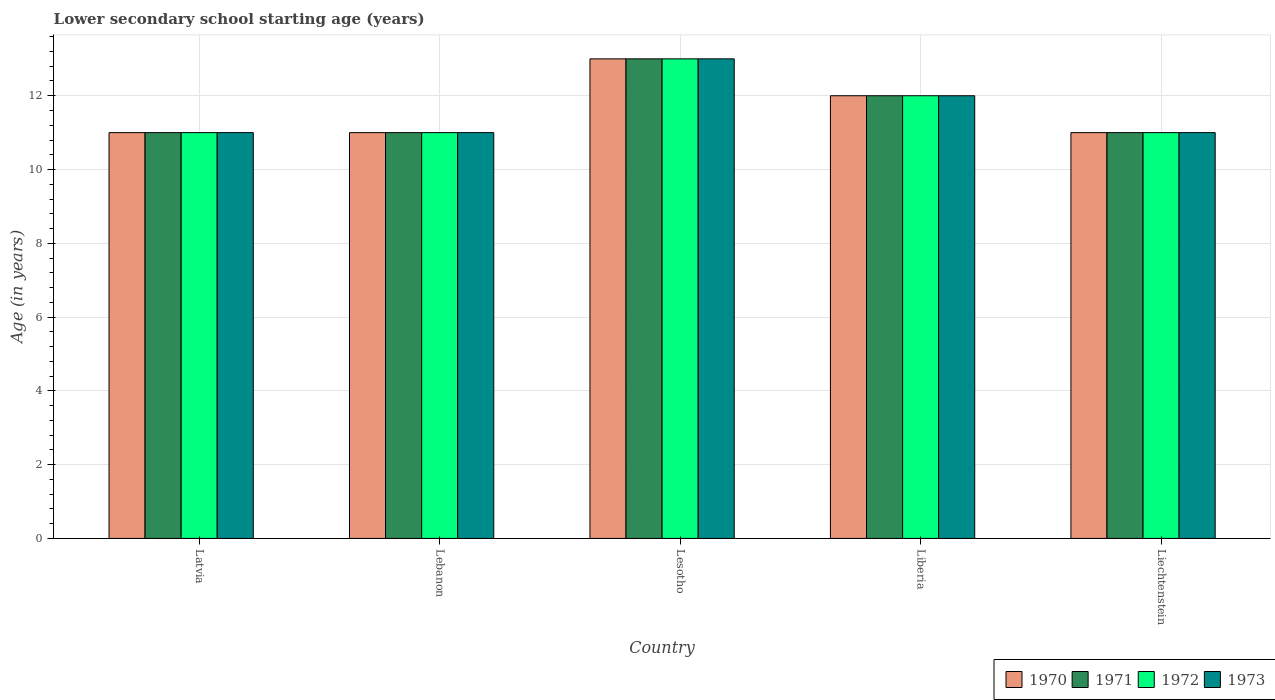How many different coloured bars are there?
Offer a terse response. 4. How many groups of bars are there?
Your answer should be compact. 5. Are the number of bars per tick equal to the number of legend labels?
Provide a succinct answer. Yes. Are the number of bars on each tick of the X-axis equal?
Give a very brief answer. Yes. What is the label of the 5th group of bars from the left?
Your response must be concise. Liechtenstein. In how many cases, is the number of bars for a given country not equal to the number of legend labels?
Your answer should be very brief. 0. Across all countries, what is the maximum lower secondary school starting age of children in 1972?
Give a very brief answer. 13. Across all countries, what is the minimum lower secondary school starting age of children in 1973?
Your response must be concise. 11. In which country was the lower secondary school starting age of children in 1973 maximum?
Ensure brevity in your answer.  Lesotho. In which country was the lower secondary school starting age of children in 1971 minimum?
Keep it short and to the point. Latvia. What is the difference between the lower secondary school starting age of children in 1973 in Lesotho and that in Liberia?
Your answer should be very brief. 1. What is the difference between the lower secondary school starting age of children of/in 1973 and lower secondary school starting age of children of/in 1972 in Latvia?
Ensure brevity in your answer.  0. What is the ratio of the lower secondary school starting age of children in 1970 in Lebanon to that in Lesotho?
Ensure brevity in your answer.  0.85. Is the lower secondary school starting age of children in 1972 in Lebanon less than that in Lesotho?
Provide a succinct answer. Yes. What is the difference between the highest and the second highest lower secondary school starting age of children in 1972?
Your answer should be compact. -1. In how many countries, is the lower secondary school starting age of children in 1973 greater than the average lower secondary school starting age of children in 1973 taken over all countries?
Your answer should be compact. 2. Is the sum of the lower secondary school starting age of children in 1972 in Liberia and Liechtenstein greater than the maximum lower secondary school starting age of children in 1971 across all countries?
Provide a succinct answer. Yes. Is it the case that in every country, the sum of the lower secondary school starting age of children in 1972 and lower secondary school starting age of children in 1971 is greater than the lower secondary school starting age of children in 1970?
Your answer should be compact. Yes. How many bars are there?
Provide a succinct answer. 20. Are all the bars in the graph horizontal?
Your answer should be compact. No. What is the difference between two consecutive major ticks on the Y-axis?
Provide a succinct answer. 2. Are the values on the major ticks of Y-axis written in scientific E-notation?
Give a very brief answer. No. Does the graph contain any zero values?
Provide a succinct answer. No. Does the graph contain grids?
Make the answer very short. Yes. Where does the legend appear in the graph?
Your answer should be very brief. Bottom right. How many legend labels are there?
Your answer should be compact. 4. What is the title of the graph?
Your answer should be compact. Lower secondary school starting age (years). Does "1994" appear as one of the legend labels in the graph?
Offer a very short reply. No. What is the label or title of the Y-axis?
Offer a very short reply. Age (in years). What is the Age (in years) in 1970 in Lebanon?
Your response must be concise. 11. What is the Age (in years) of 1973 in Lebanon?
Ensure brevity in your answer.  11. What is the Age (in years) in 1971 in Lesotho?
Your answer should be very brief. 13. What is the Age (in years) of 1972 in Lesotho?
Give a very brief answer. 13. What is the Age (in years) in 1971 in Liechtenstein?
Provide a short and direct response. 11. Across all countries, what is the maximum Age (in years) in 1970?
Provide a short and direct response. 13. Across all countries, what is the maximum Age (in years) of 1972?
Offer a terse response. 13. Across all countries, what is the maximum Age (in years) of 1973?
Give a very brief answer. 13. Across all countries, what is the minimum Age (in years) in 1971?
Offer a terse response. 11. Across all countries, what is the minimum Age (in years) in 1972?
Make the answer very short. 11. Across all countries, what is the minimum Age (in years) of 1973?
Give a very brief answer. 11. What is the total Age (in years) in 1970 in the graph?
Make the answer very short. 58. What is the total Age (in years) of 1972 in the graph?
Make the answer very short. 58. What is the difference between the Age (in years) of 1972 in Latvia and that in Lebanon?
Your answer should be very brief. 0. What is the difference between the Age (in years) of 1971 in Latvia and that in Liberia?
Make the answer very short. -1. What is the difference between the Age (in years) of 1973 in Latvia and that in Liberia?
Offer a very short reply. -1. What is the difference between the Age (in years) in 1970 in Latvia and that in Liechtenstein?
Offer a very short reply. 0. What is the difference between the Age (in years) in 1971 in Latvia and that in Liechtenstein?
Ensure brevity in your answer.  0. What is the difference between the Age (in years) of 1972 in Latvia and that in Liechtenstein?
Give a very brief answer. 0. What is the difference between the Age (in years) of 1973 in Latvia and that in Liechtenstein?
Provide a short and direct response. 0. What is the difference between the Age (in years) of 1972 in Lebanon and that in Liberia?
Your response must be concise. -1. What is the difference between the Age (in years) of 1970 in Lebanon and that in Liechtenstein?
Your answer should be compact. 0. What is the difference between the Age (in years) of 1971 in Lebanon and that in Liechtenstein?
Your response must be concise. 0. What is the difference between the Age (in years) in 1972 in Lebanon and that in Liechtenstein?
Offer a very short reply. 0. What is the difference between the Age (in years) in 1970 in Lesotho and that in Liberia?
Provide a short and direct response. 1. What is the difference between the Age (in years) of 1971 in Lesotho and that in Liberia?
Keep it short and to the point. 1. What is the difference between the Age (in years) in 1972 in Lesotho and that in Liberia?
Ensure brevity in your answer.  1. What is the difference between the Age (in years) in 1970 in Lesotho and that in Liechtenstein?
Your answer should be compact. 2. What is the difference between the Age (in years) in 1971 in Lesotho and that in Liechtenstein?
Give a very brief answer. 2. What is the difference between the Age (in years) in 1972 in Lesotho and that in Liechtenstein?
Your answer should be compact. 2. What is the difference between the Age (in years) of 1973 in Lesotho and that in Liechtenstein?
Provide a short and direct response. 2. What is the difference between the Age (in years) in 1973 in Liberia and that in Liechtenstein?
Offer a very short reply. 1. What is the difference between the Age (in years) of 1970 in Latvia and the Age (in years) of 1971 in Lebanon?
Give a very brief answer. 0. What is the difference between the Age (in years) in 1970 in Latvia and the Age (in years) in 1973 in Lebanon?
Offer a very short reply. 0. What is the difference between the Age (in years) in 1971 in Latvia and the Age (in years) in 1972 in Lebanon?
Your answer should be compact. 0. What is the difference between the Age (in years) in 1972 in Latvia and the Age (in years) in 1973 in Lebanon?
Make the answer very short. 0. What is the difference between the Age (in years) in 1970 in Latvia and the Age (in years) in 1971 in Lesotho?
Make the answer very short. -2. What is the difference between the Age (in years) in 1971 in Latvia and the Age (in years) in 1972 in Lesotho?
Offer a very short reply. -2. What is the difference between the Age (in years) in 1971 in Latvia and the Age (in years) in 1973 in Lesotho?
Offer a very short reply. -2. What is the difference between the Age (in years) of 1972 in Latvia and the Age (in years) of 1973 in Lesotho?
Keep it short and to the point. -2. What is the difference between the Age (in years) of 1970 in Latvia and the Age (in years) of 1971 in Liberia?
Your answer should be very brief. -1. What is the difference between the Age (in years) in 1970 in Latvia and the Age (in years) in 1972 in Liberia?
Offer a very short reply. -1. What is the difference between the Age (in years) in 1970 in Latvia and the Age (in years) in 1973 in Liberia?
Give a very brief answer. -1. What is the difference between the Age (in years) in 1971 in Latvia and the Age (in years) in 1972 in Liberia?
Offer a very short reply. -1. What is the difference between the Age (in years) in 1970 in Latvia and the Age (in years) in 1972 in Liechtenstein?
Make the answer very short. 0. What is the difference between the Age (in years) in 1971 in Latvia and the Age (in years) in 1972 in Liechtenstein?
Provide a succinct answer. 0. What is the difference between the Age (in years) in 1972 in Latvia and the Age (in years) in 1973 in Liechtenstein?
Provide a succinct answer. 0. What is the difference between the Age (in years) of 1971 in Lebanon and the Age (in years) of 1973 in Lesotho?
Offer a very short reply. -2. What is the difference between the Age (in years) of 1971 in Lebanon and the Age (in years) of 1972 in Liberia?
Provide a succinct answer. -1. What is the difference between the Age (in years) of 1971 in Lebanon and the Age (in years) of 1973 in Liberia?
Provide a short and direct response. -1. What is the difference between the Age (in years) of 1972 in Lebanon and the Age (in years) of 1973 in Liberia?
Your answer should be very brief. -1. What is the difference between the Age (in years) of 1970 in Lebanon and the Age (in years) of 1971 in Liechtenstein?
Offer a very short reply. 0. What is the difference between the Age (in years) in 1970 in Lebanon and the Age (in years) in 1972 in Liechtenstein?
Give a very brief answer. 0. What is the difference between the Age (in years) in 1971 in Lebanon and the Age (in years) in 1972 in Liechtenstein?
Your response must be concise. 0. What is the difference between the Age (in years) of 1971 in Lebanon and the Age (in years) of 1973 in Liechtenstein?
Make the answer very short. 0. What is the difference between the Age (in years) of 1970 in Lesotho and the Age (in years) of 1971 in Liberia?
Provide a short and direct response. 1. What is the difference between the Age (in years) in 1970 in Lesotho and the Age (in years) in 1972 in Liberia?
Your response must be concise. 1. What is the difference between the Age (in years) in 1972 in Lesotho and the Age (in years) in 1973 in Liberia?
Offer a terse response. 1. What is the difference between the Age (in years) of 1970 in Lesotho and the Age (in years) of 1972 in Liechtenstein?
Offer a very short reply. 2. What is the difference between the Age (in years) of 1971 in Lesotho and the Age (in years) of 1972 in Liechtenstein?
Your answer should be compact. 2. What is the difference between the Age (in years) in 1972 in Lesotho and the Age (in years) in 1973 in Liechtenstein?
Ensure brevity in your answer.  2. What is the difference between the Age (in years) of 1970 in Liberia and the Age (in years) of 1971 in Liechtenstein?
Offer a very short reply. 1. What is the difference between the Age (in years) in 1971 in Liberia and the Age (in years) in 1972 in Liechtenstein?
Give a very brief answer. 1. What is the difference between the Age (in years) of 1972 in Liberia and the Age (in years) of 1973 in Liechtenstein?
Offer a very short reply. 1. What is the average Age (in years) in 1970 per country?
Your answer should be very brief. 11.6. What is the average Age (in years) of 1971 per country?
Your answer should be compact. 11.6. What is the average Age (in years) of 1972 per country?
Provide a short and direct response. 11.6. What is the average Age (in years) of 1973 per country?
Ensure brevity in your answer.  11.6. What is the difference between the Age (in years) of 1970 and Age (in years) of 1972 in Latvia?
Your response must be concise. 0. What is the difference between the Age (in years) of 1971 and Age (in years) of 1972 in Latvia?
Ensure brevity in your answer.  0. What is the difference between the Age (in years) in 1971 and Age (in years) in 1973 in Latvia?
Your response must be concise. 0. What is the difference between the Age (in years) in 1972 and Age (in years) in 1973 in Latvia?
Your answer should be very brief. 0. What is the difference between the Age (in years) of 1970 and Age (in years) of 1971 in Lebanon?
Provide a succinct answer. 0. What is the difference between the Age (in years) in 1970 and Age (in years) in 1972 in Lebanon?
Provide a short and direct response. 0. What is the difference between the Age (in years) of 1970 and Age (in years) of 1973 in Lebanon?
Make the answer very short. 0. What is the difference between the Age (in years) in 1971 and Age (in years) in 1972 in Lebanon?
Your answer should be compact. 0. What is the difference between the Age (in years) of 1971 and Age (in years) of 1973 in Lebanon?
Offer a terse response. 0. What is the difference between the Age (in years) of 1970 and Age (in years) of 1972 in Lesotho?
Your answer should be compact. 0. What is the difference between the Age (in years) of 1971 and Age (in years) of 1972 in Lesotho?
Give a very brief answer. 0. What is the difference between the Age (in years) of 1971 and Age (in years) of 1973 in Lesotho?
Your answer should be compact. 0. What is the difference between the Age (in years) of 1972 and Age (in years) of 1973 in Lesotho?
Keep it short and to the point. 0. What is the difference between the Age (in years) of 1970 and Age (in years) of 1971 in Liberia?
Your answer should be very brief. 0. What is the difference between the Age (in years) in 1970 and Age (in years) in 1972 in Liberia?
Provide a short and direct response. 0. What is the difference between the Age (in years) in 1970 and Age (in years) in 1973 in Liberia?
Keep it short and to the point. 0. What is the difference between the Age (in years) of 1970 and Age (in years) of 1971 in Liechtenstein?
Give a very brief answer. 0. What is the difference between the Age (in years) of 1970 and Age (in years) of 1973 in Liechtenstein?
Provide a short and direct response. 0. What is the difference between the Age (in years) of 1972 and Age (in years) of 1973 in Liechtenstein?
Your response must be concise. 0. What is the ratio of the Age (in years) in 1970 in Latvia to that in Lebanon?
Offer a terse response. 1. What is the ratio of the Age (in years) in 1971 in Latvia to that in Lebanon?
Offer a terse response. 1. What is the ratio of the Age (in years) in 1973 in Latvia to that in Lebanon?
Keep it short and to the point. 1. What is the ratio of the Age (in years) of 1970 in Latvia to that in Lesotho?
Give a very brief answer. 0.85. What is the ratio of the Age (in years) of 1971 in Latvia to that in Lesotho?
Give a very brief answer. 0.85. What is the ratio of the Age (in years) of 1972 in Latvia to that in Lesotho?
Ensure brevity in your answer.  0.85. What is the ratio of the Age (in years) in 1973 in Latvia to that in Lesotho?
Keep it short and to the point. 0.85. What is the ratio of the Age (in years) in 1970 in Latvia to that in Liberia?
Provide a short and direct response. 0.92. What is the ratio of the Age (in years) of 1973 in Latvia to that in Liberia?
Your response must be concise. 0.92. What is the ratio of the Age (in years) of 1970 in Latvia to that in Liechtenstein?
Your answer should be compact. 1. What is the ratio of the Age (in years) of 1973 in Latvia to that in Liechtenstein?
Your answer should be compact. 1. What is the ratio of the Age (in years) of 1970 in Lebanon to that in Lesotho?
Provide a short and direct response. 0.85. What is the ratio of the Age (in years) of 1971 in Lebanon to that in Lesotho?
Your answer should be very brief. 0.85. What is the ratio of the Age (in years) in 1972 in Lebanon to that in Lesotho?
Make the answer very short. 0.85. What is the ratio of the Age (in years) of 1973 in Lebanon to that in Lesotho?
Your answer should be very brief. 0.85. What is the ratio of the Age (in years) of 1971 in Lebanon to that in Liberia?
Keep it short and to the point. 0.92. What is the ratio of the Age (in years) of 1973 in Lebanon to that in Liberia?
Offer a terse response. 0.92. What is the ratio of the Age (in years) of 1971 in Lebanon to that in Liechtenstein?
Make the answer very short. 1. What is the ratio of the Age (in years) in 1973 in Lebanon to that in Liechtenstein?
Your answer should be compact. 1. What is the ratio of the Age (in years) in 1970 in Lesotho to that in Liberia?
Offer a terse response. 1.08. What is the ratio of the Age (in years) in 1972 in Lesotho to that in Liberia?
Ensure brevity in your answer.  1.08. What is the ratio of the Age (in years) of 1970 in Lesotho to that in Liechtenstein?
Make the answer very short. 1.18. What is the ratio of the Age (in years) of 1971 in Lesotho to that in Liechtenstein?
Give a very brief answer. 1.18. What is the ratio of the Age (in years) of 1972 in Lesotho to that in Liechtenstein?
Your response must be concise. 1.18. What is the ratio of the Age (in years) of 1973 in Lesotho to that in Liechtenstein?
Offer a very short reply. 1.18. What is the ratio of the Age (in years) in 1970 in Liberia to that in Liechtenstein?
Provide a short and direct response. 1.09. What is the ratio of the Age (in years) in 1973 in Liberia to that in Liechtenstein?
Provide a short and direct response. 1.09. What is the difference between the highest and the second highest Age (in years) in 1971?
Offer a very short reply. 1. What is the difference between the highest and the second highest Age (in years) of 1972?
Make the answer very short. 1. What is the difference between the highest and the second highest Age (in years) in 1973?
Keep it short and to the point. 1. What is the difference between the highest and the lowest Age (in years) of 1970?
Offer a very short reply. 2. What is the difference between the highest and the lowest Age (in years) of 1971?
Your response must be concise. 2. What is the difference between the highest and the lowest Age (in years) of 1972?
Your response must be concise. 2. What is the difference between the highest and the lowest Age (in years) of 1973?
Offer a terse response. 2. 